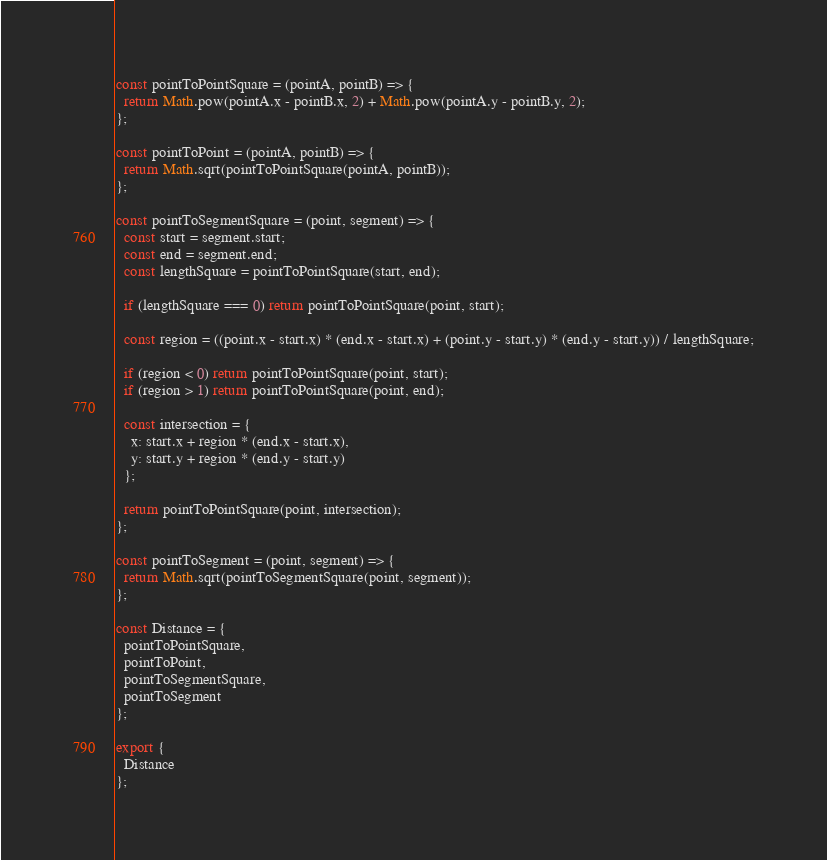Convert code to text. <code><loc_0><loc_0><loc_500><loc_500><_JavaScript_>const pointToPointSquare = (pointA, pointB) => {
  return Math.pow(pointA.x - pointB.x, 2) + Math.pow(pointA.y - pointB.y, 2);
};

const pointToPoint = (pointA, pointB) => {
  return Math.sqrt(pointToPointSquare(pointA, pointB));
};

const pointToSegmentSquare = (point, segment) => {
  const start = segment.start;
  const end = segment.end;
  const lengthSquare = pointToPointSquare(start, end);

  if (lengthSquare === 0) return pointToPointSquare(point, start);

  const region = ((point.x - start.x) * (end.x - start.x) + (point.y - start.y) * (end.y - start.y)) / lengthSquare;

  if (region < 0) return pointToPointSquare(point, start);
  if (region > 1) return pointToPointSquare(point, end);

  const intersection = {
    x: start.x + region * (end.x - start.x),
    y: start.y + region * (end.y - start.y)
  };

  return pointToPointSquare(point, intersection);
};

const pointToSegment = (point, segment) => {
  return Math.sqrt(pointToSegmentSquare(point, segment));
};

const Distance = {
  pointToPointSquare,
  pointToPoint,
  pointToSegmentSquare,
  pointToSegment
};

export {
  Distance
};
</code> 